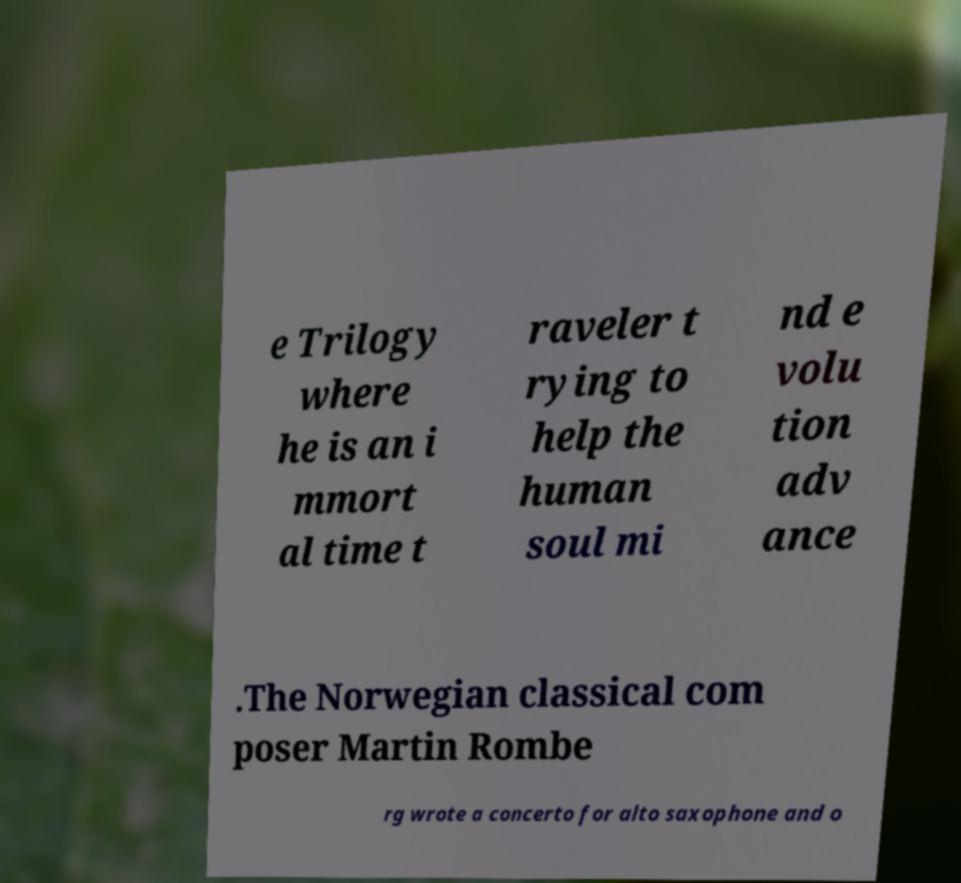Can you accurately transcribe the text from the provided image for me? e Trilogy where he is an i mmort al time t raveler t rying to help the human soul mi nd e volu tion adv ance .The Norwegian classical com poser Martin Rombe rg wrote a concerto for alto saxophone and o 